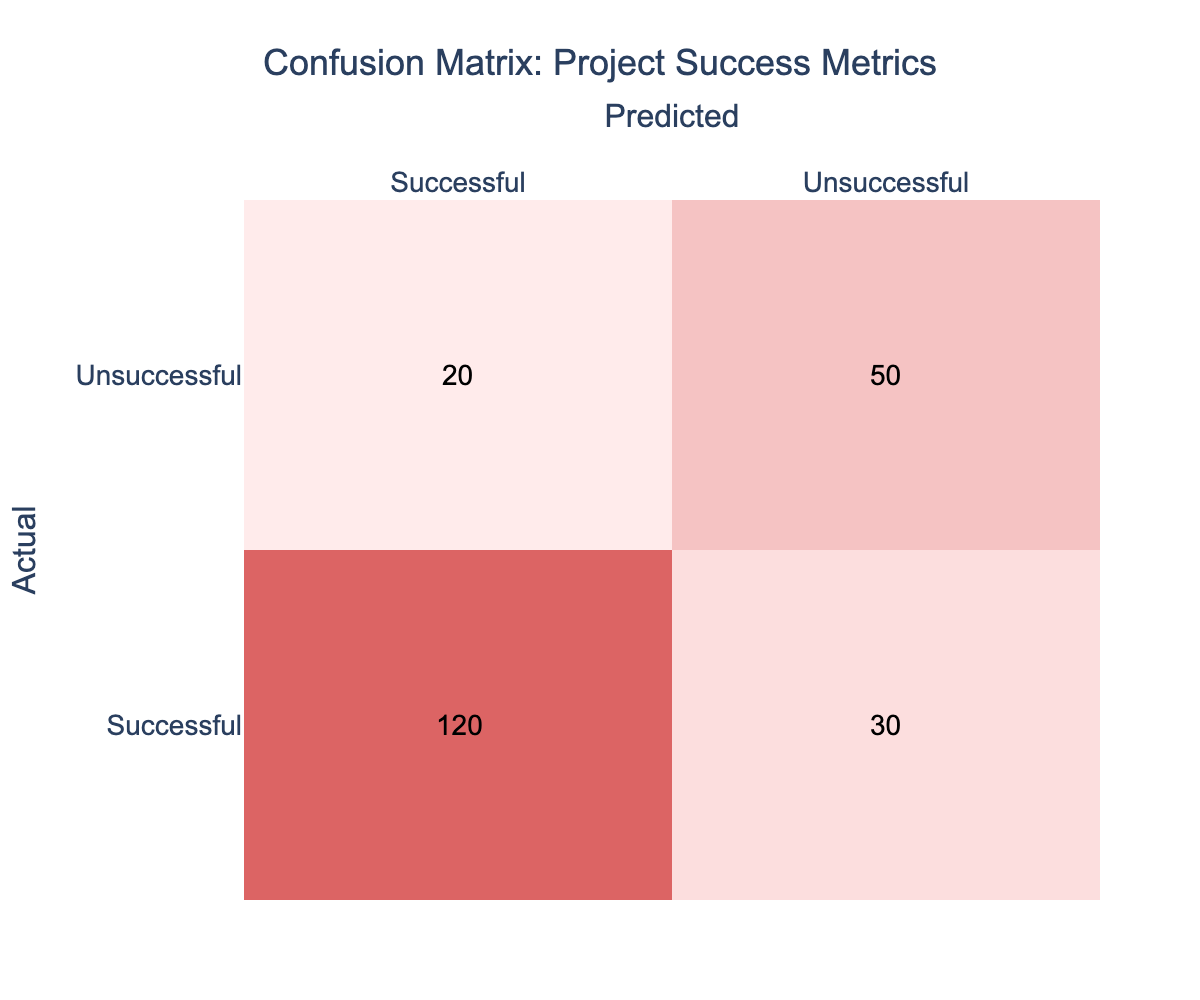What is the total number of successful projects as per the predicted results? The predicted results for successful projects include 120 cases identified as successful. Therefore, when asked about the total number of successful projects, we can directly take the value from the table.
Answer: 120 What is the total number of unsuccessful projects in reality? The actual results show that there are 50 cases classified as unsuccessful projects. This is directly referenced from the table.
Answer: 50 How many projects were correctly predicted to be unsuccessful? The number of projects correctly predicted as unsuccessful is found in the "Unsuccessful" row and "Unsuccessful" column of the table, which shows a value of 50.
Answer: 50 What percentage of projects predicted to be successful were actually unsuccessful? To calculate this percentage, we take the number of unsuccessful predictions (30) out of the total predictions for successful projects (120 + 30 = 150). Thus, the percentage is (30 / 150) * 100 = 20%.
Answer: 20% Are there more successful or unsuccessful projects according to the actual data? Looking at the actual data, successful projects count is 120 compared to unsuccessful projects which count 50. Since 120 is greater than 50, this means there are more successful projects.
Answer: Yes What is the proportion of correctly predicted successful projects to the total number of predicted projects? The number of correctly predicted successful projects is 120. The total number of predicted projects is the sum of successful and unsuccessful predictions: 120 + 30 = 150. The proportion is therefore 120 / 150 = 0.8, or 80%.
Answer: 80% What is the sum of all actual classifications in the matrix? We sum up all the values in the confusion matrix: 120 (successful-successful) + 30 (successful-unsuccessful) + 20 (unsuccessful-successful) + 50 (unsuccessful-unsuccessful) = 220. This gives us the total actual classifications.
Answer: 220 Which prediction had the highest number of projects classified as successful? In the confusion matrix, the "Successful" predictions hold the highest value of 120 from the "Successful" row. This indicates that the highest number of projects predicted as successful was accurately classified as such.
Answer: 120 What is the difference between the actual successful and actual unsuccessful projects? From the actual results, there are 120 successful projects and 50 unsuccessful projects. The difference is calculated as 120 - 50 = 70, which indicates the margin between the two classifications.
Answer: 70 